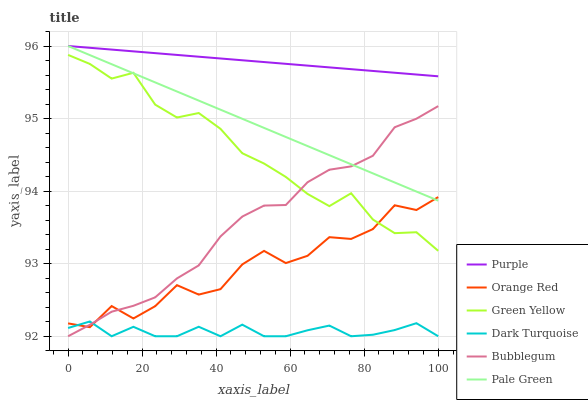Does Bubblegum have the minimum area under the curve?
Answer yes or no. No. Does Bubblegum have the maximum area under the curve?
Answer yes or no. No. Is Dark Turquoise the smoothest?
Answer yes or no. No. Is Dark Turquoise the roughest?
Answer yes or no. No. Does Pale Green have the lowest value?
Answer yes or no. No. Does Bubblegum have the highest value?
Answer yes or no. No. Is Dark Turquoise less than Pale Green?
Answer yes or no. Yes. Is Purple greater than Bubblegum?
Answer yes or no. Yes. Does Dark Turquoise intersect Pale Green?
Answer yes or no. No. 